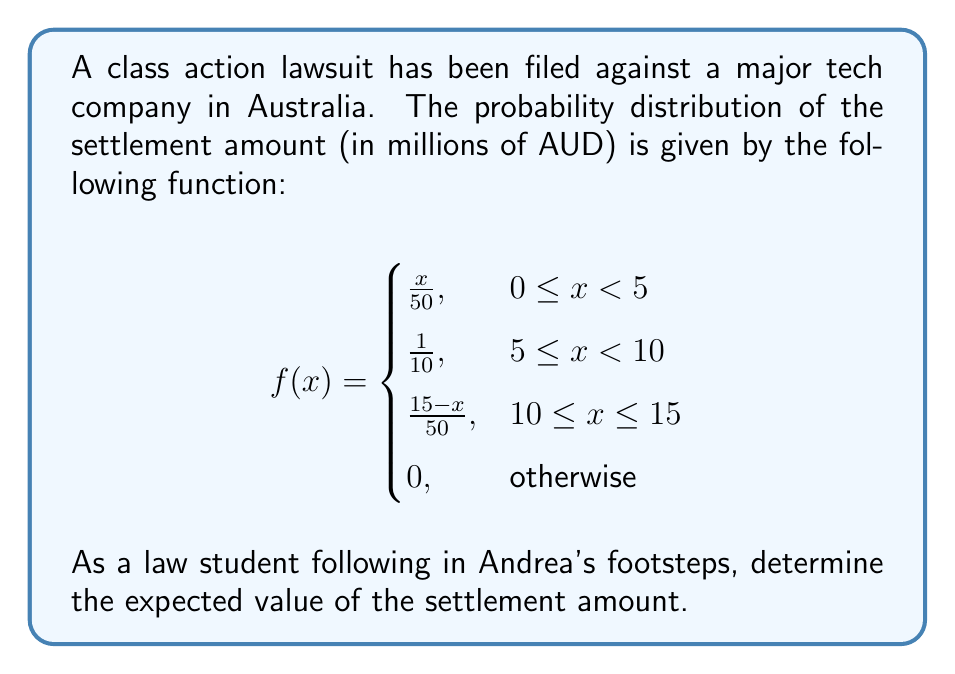Can you solve this math problem? To find the expected value, we need to calculate:

$$E[X] = \int_{-\infty}^{\infty} xf(x)dx$$

Given the piecewise function, we'll split this into three integrals:

1. For $0 \leq x < 5$:
   $$\int_0^5 x \cdot \frac{x}{50}dx = \frac{1}{50}\int_0^5 x^2dx = \frac{1}{50} \cdot \frac{x^3}{3}\bigg|_0^5 = \frac{125}{150} = \frac{5}{6}$$

2. For $5 \leq x < 10$:
   $$\int_5^{10} x \cdot \frac{1}{10}dx = \frac{1}{10}\int_5^{10} xdx = \frac{1}{10} \cdot \frac{x^2}{2}\bigg|_5^{10} = \frac{75}{10} = \frac{15}{2}$$

3. For $10 \leq x \leq 15$:
   $$\int_{10}^{15} x \cdot \frac{15-x}{50}dx = \frac{1}{50}\int_{10}^{15} (15x - x^2)dx = \frac{1}{50} \cdot \left(\frac{15x^2}{2} - \frac{x^3}{3}\right)\bigg|_{10}^{15} = \frac{125}{6}$$

Sum these results:

$$E[X] = \frac{5}{6} + \frac{15}{2} + \frac{125}{6} = \frac{5}{6} + \frac{45}{6} + \frac{125}{6} = \frac{175}{6} \approx 29.17$$

Thus, the expected value of the settlement is approximately 29.17 million AUD.
Answer: $\frac{175}{6}$ million AUD 